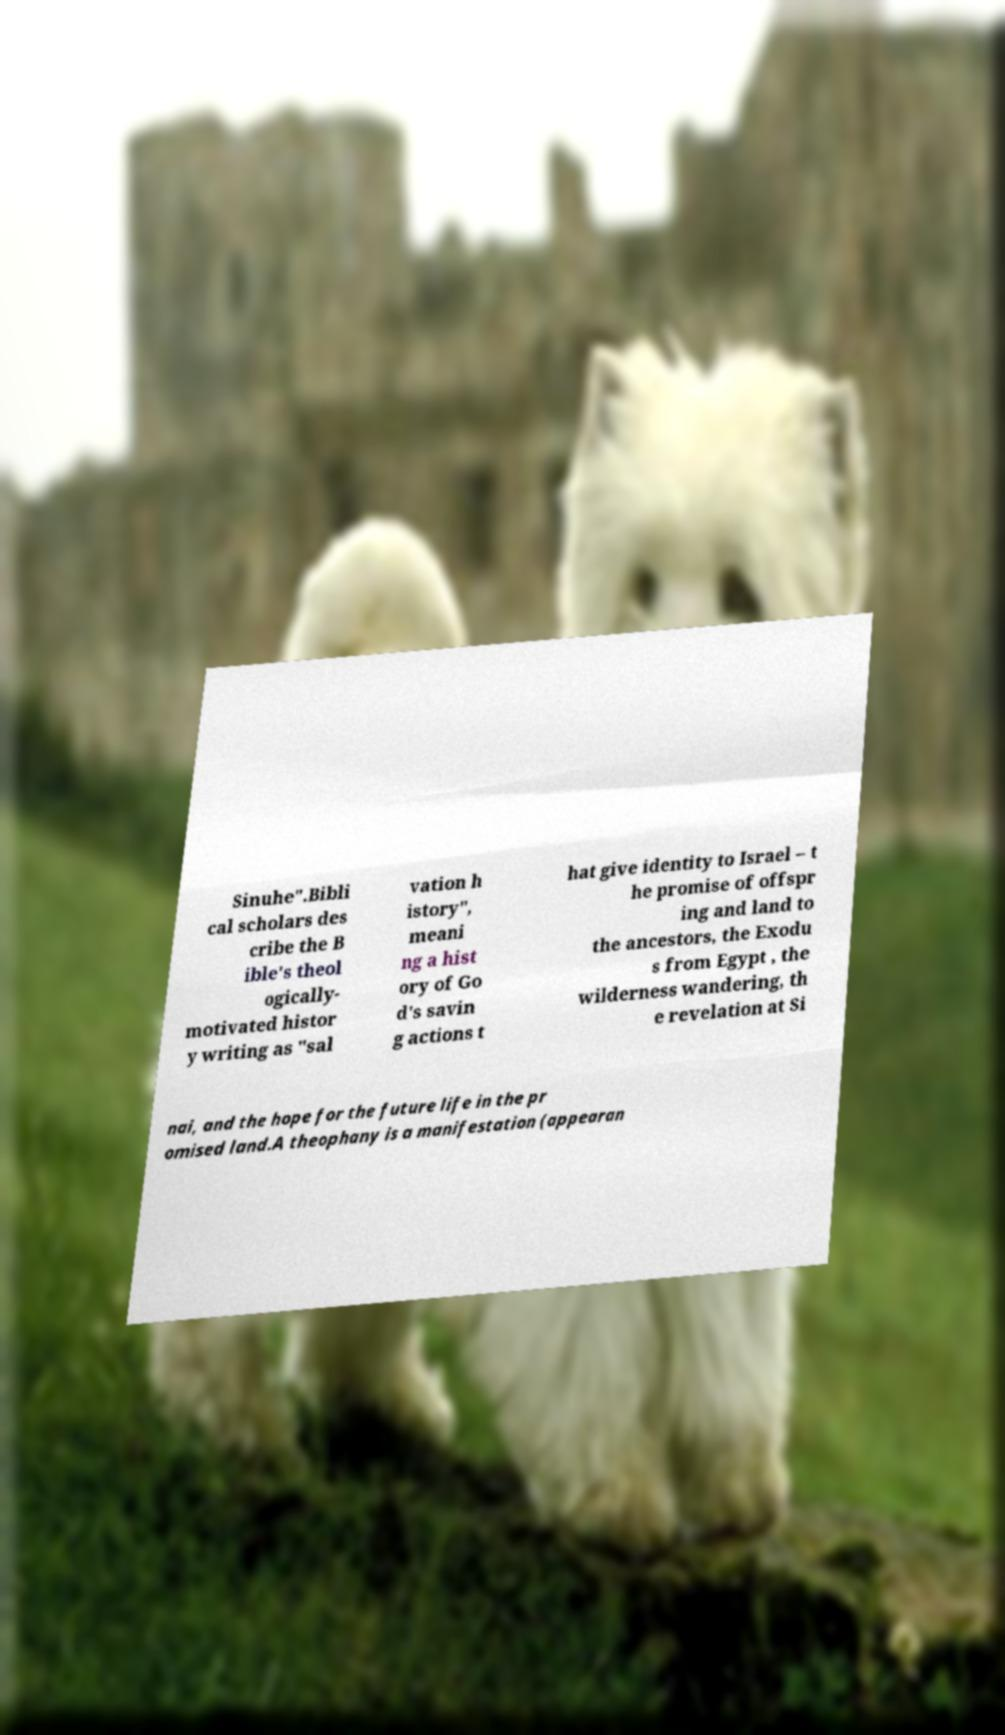Please identify and transcribe the text found in this image. Sinuhe".Bibli cal scholars des cribe the B ible's theol ogically- motivated histor y writing as "sal vation h istory", meani ng a hist ory of Go d's savin g actions t hat give identity to Israel – t he promise of offspr ing and land to the ancestors, the Exodu s from Egypt , the wilderness wandering, th e revelation at Si nai, and the hope for the future life in the pr omised land.A theophany is a manifestation (appearan 